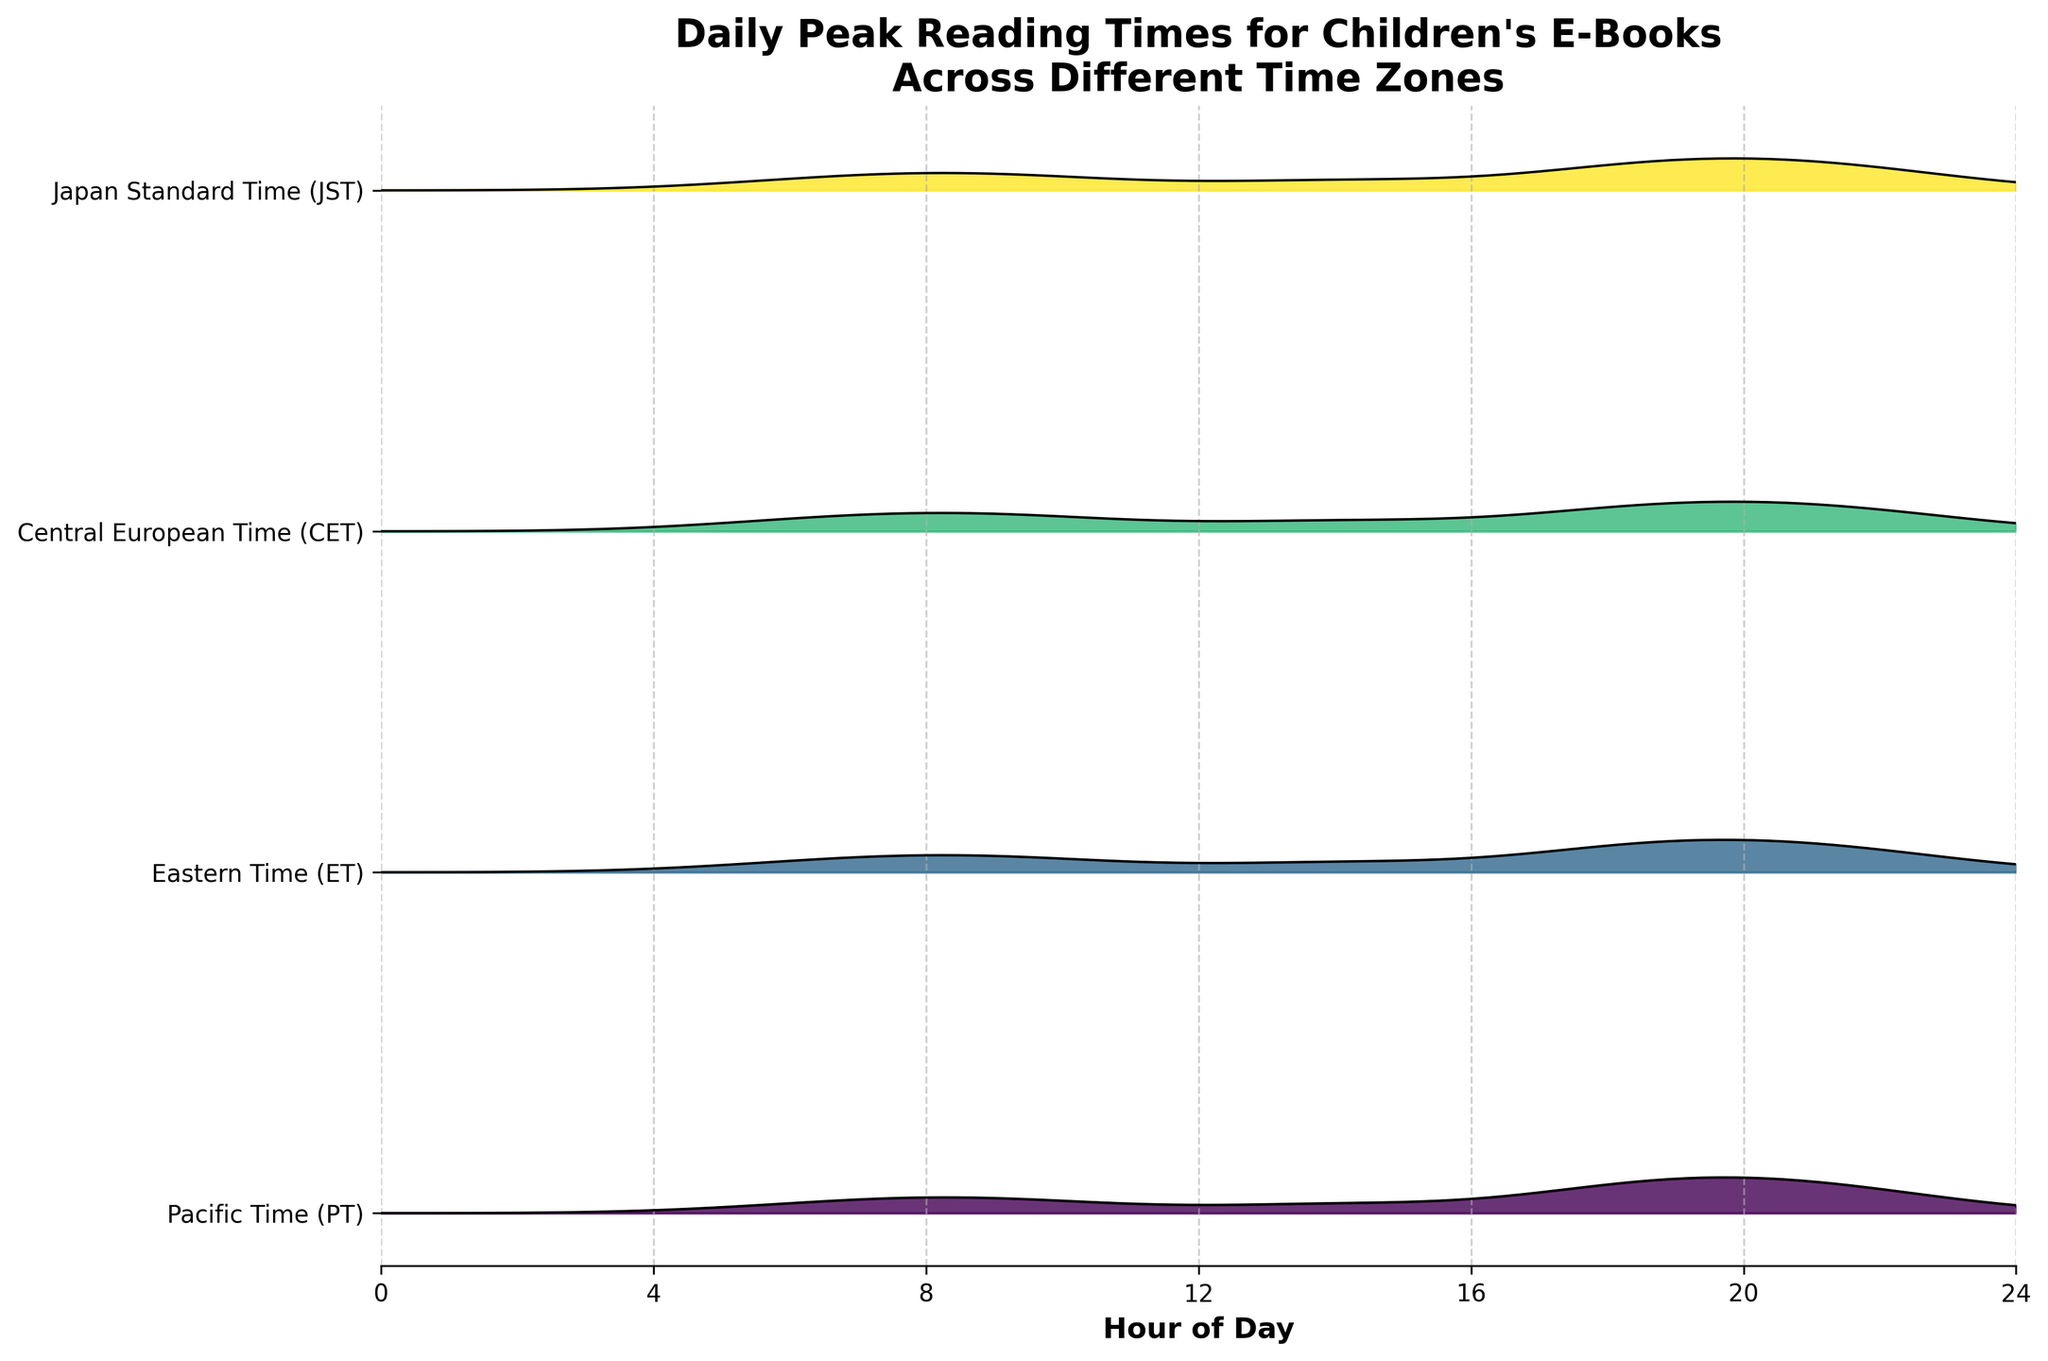What's the title of the figure? The title of the figure is typically displayed at the top of the chart. In this case, it reads "Daily Peak Reading Times for Children's E-Books Across Different Time Zones."
Answer: Daily Peak Reading Times for Children's E-Books Across Different Time Zones How many time zones are represented in the figure? The number of unique time zones can be determined by counting the unique labels along the y-axis of the Ridgeline plot. There are labels for Pacific Time (PT), Eastern Time (ET), Central European Time (CET), and Japan Standard Time (JST).
Answer: 4 At what hour do Pacific Time (PT) and Eastern Time (ET) both show peak reading density? To determine the peak reading density hour, observe the highest points in the graph for both Pacific Time (PT) and Eastern Time (ET). Both peaks are at the hour labeled 20.
Answer: 20 Which time zone has the highest peak reading density and at what hour? By observing the plot, the highest peak reading density for each time zone can be seen around the hour lines. Central European Time (CET) has the highest peak at the hour 20.
Answer: Central European Time (CET), hour 20 Describe the trend in reading density for Japan Standard Time (JST) throughout the day. Analyze the ups and downs in the filled curve for JST. The reading density starts low, slightly increases, dips, then rises again, hitting its peak at hour 20 before dropping again.
Answer: Low, slight increase in the morning, dip, peak at hour 20, drops again Is there a time when all four time zones show relatively high reading densities? Look for a common time across all four time zones where the density values are near their highest peaks. The graph shows that around hour 20, all time zones have a high reading density.
Answer: Around hour 20 Compare the peak reading times for Pacific Time (PT) and Central European Time (CET). Which is higher and by how much? The highest peaks for PT and CET are at hours 20. The peak reading density for PT at 20 is 1.0, and for CET, it is also 1.0. The heights are equal.
Answer: Both are 1.0, no difference What is the reading density for Eastern Time (ET) at hour 18? Examine the figure to find the density value at hour 18 for Eastern Time (ET). According to the figure, the density is 0.9.
Answer: 0.9 Which time zone shows a peak reading density earliest in the day and at what time? Determine the earliest peak by comparing the high points in the filled curves across time zones. Central European Time (CET) shows a notable peak density first at hour 8.
Answer: Central European Time (CET), hour 8 